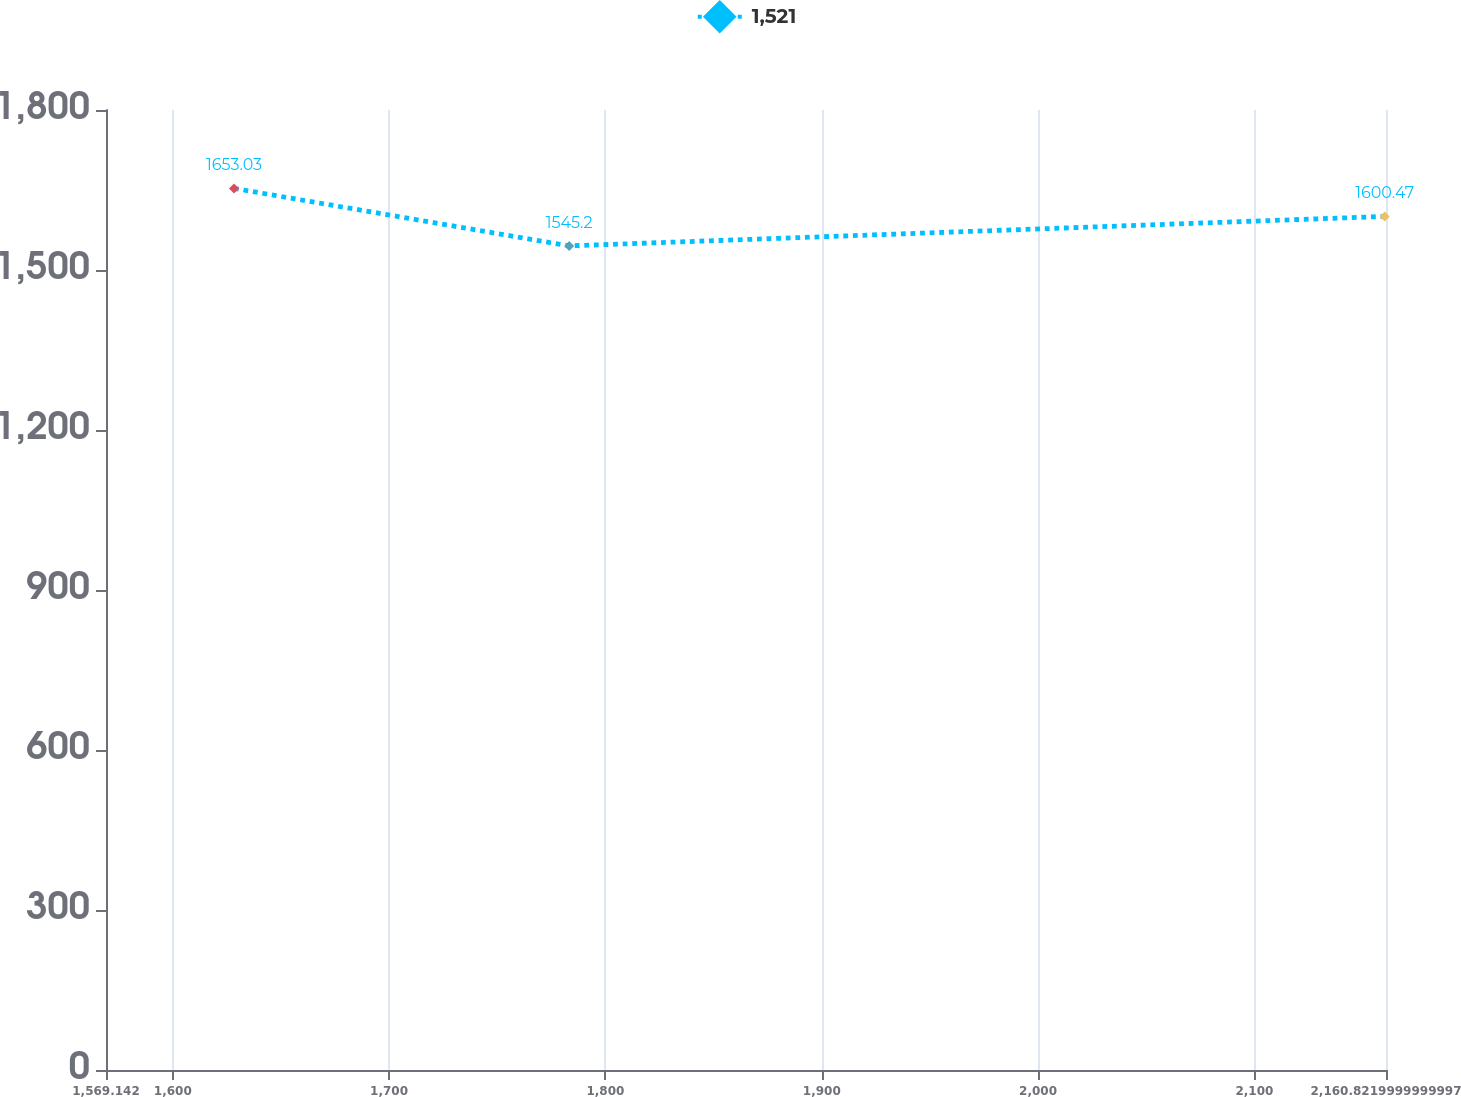<chart> <loc_0><loc_0><loc_500><loc_500><line_chart><ecel><fcel>1,521<nl><fcel>1628.31<fcel>1653.03<nl><fcel>1783.24<fcel>1545.2<nl><fcel>2160.21<fcel>1600.47<nl><fcel>2219.99<fcel>1579.7<nl></chart> 